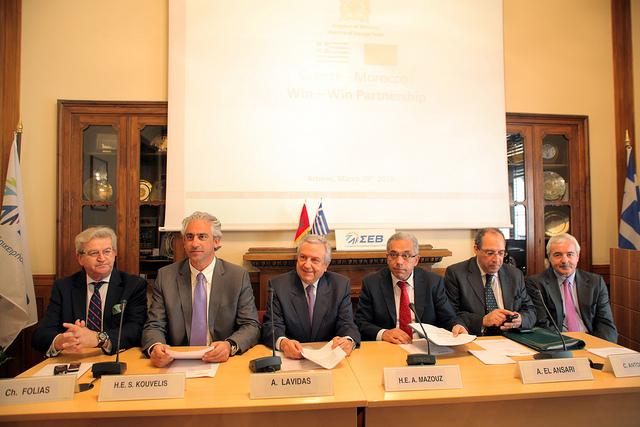Are these young people?
Answer briefly. No. How many men are wearing pink ties?
Short answer required. 1. What is the man doing?
Short answer required. Sitting. Is the man on the far right smiling?
Concise answer only. Yes. 